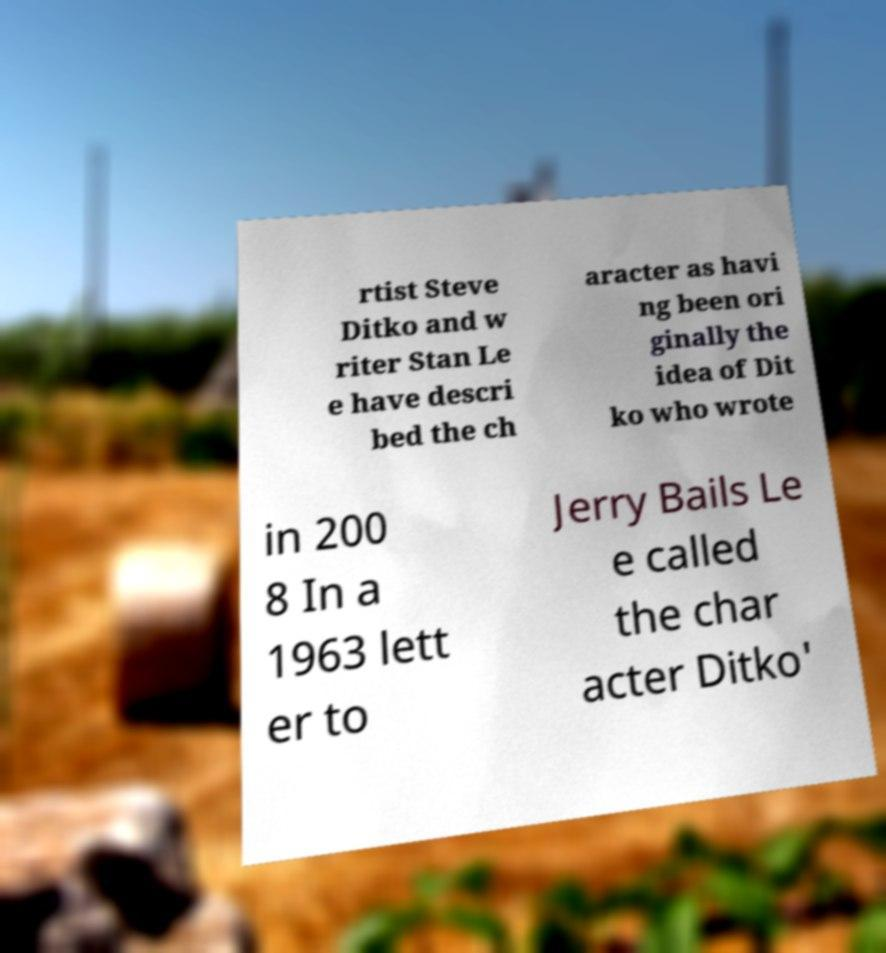Please identify and transcribe the text found in this image. rtist Steve Ditko and w riter Stan Le e have descri bed the ch aracter as havi ng been ori ginally the idea of Dit ko who wrote in 200 8 In a 1963 lett er to Jerry Bails Le e called the char acter Ditko' 